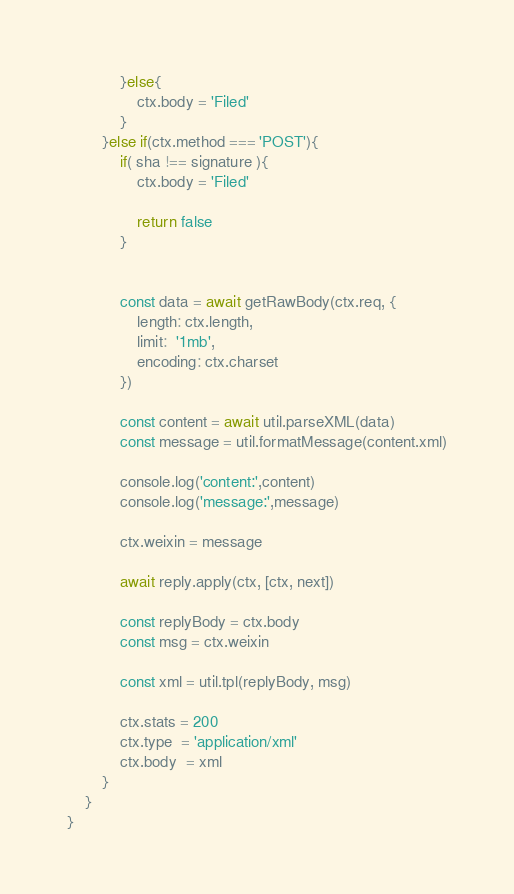Convert code to text. <code><loc_0><loc_0><loc_500><loc_500><_JavaScript_>			}else{
				ctx.body = 'Filed'
			}
		}else if(ctx.method === 'POST'){
			if( sha !== signature ){
				ctx.body = 'Filed'
				
				return false
			}


			const data = await getRawBody(ctx.req, {
				length: ctx.length,
				limit:  '1mb',
				encoding: ctx.charset
			})

			const content = await util.parseXML(data)
			const message = util.formatMessage(content.xml)

			console.log('content:',content)
			console.log('message:',message)

			ctx.weixin = message

			await reply.apply(ctx, [ctx, next])

			const replyBody = ctx.body
			const msg = ctx.weixin

			const xml = util.tpl(replyBody, msg)

			ctx.stats = 200
			ctx.type  = 'application/xml'
			ctx.body  = xml
		}
	}
}</code> 